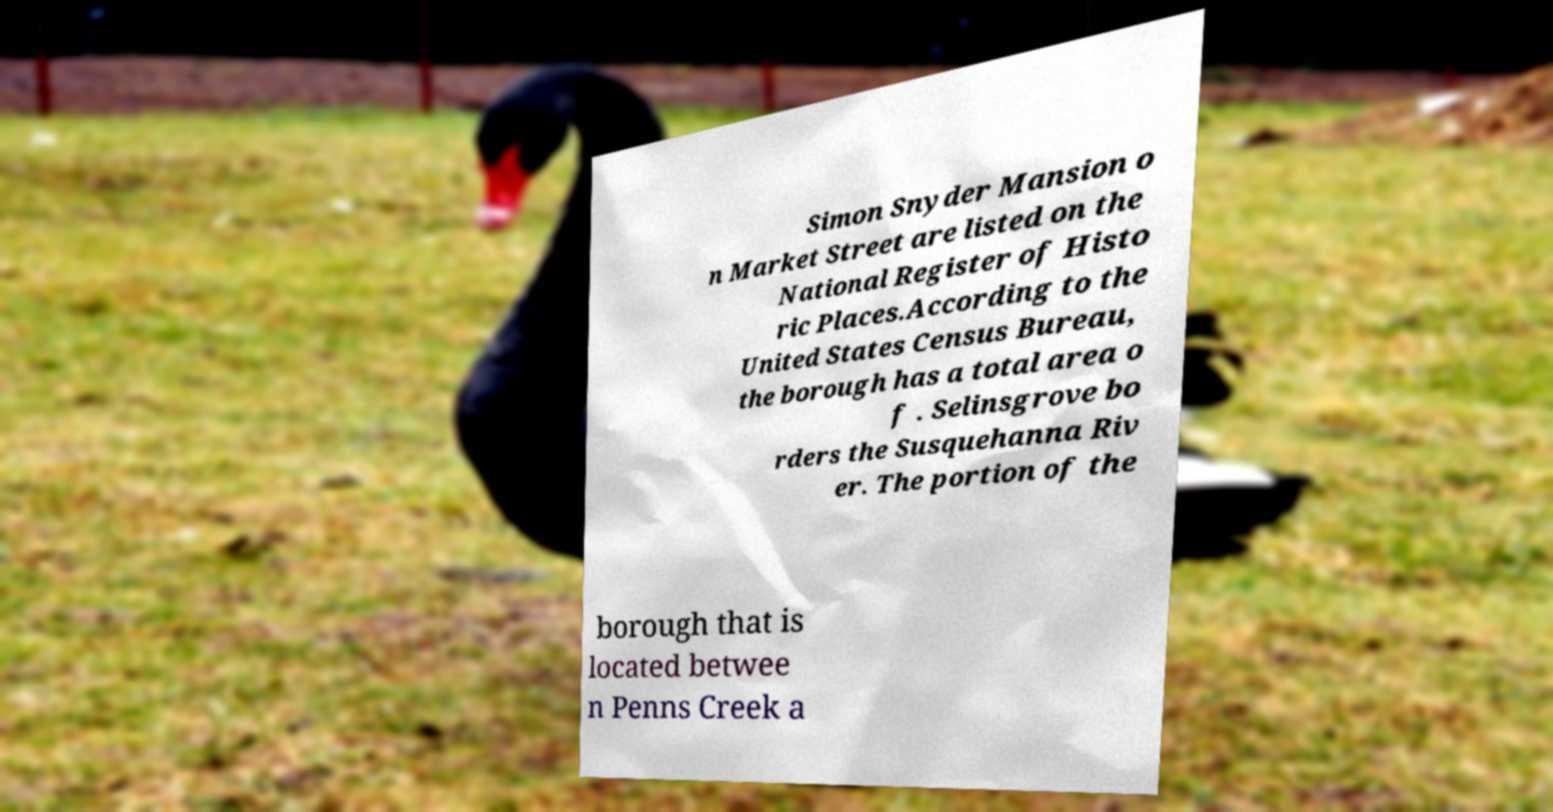Can you read and provide the text displayed in the image?This photo seems to have some interesting text. Can you extract and type it out for me? Simon Snyder Mansion o n Market Street are listed on the National Register of Histo ric Places.According to the United States Census Bureau, the borough has a total area o f . Selinsgrove bo rders the Susquehanna Riv er. The portion of the borough that is located betwee n Penns Creek a 